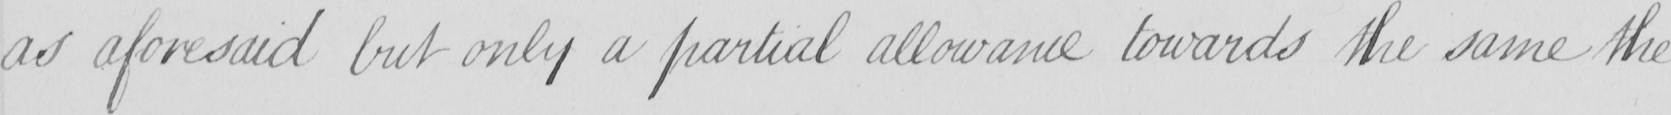Please transcribe the handwritten text in this image. as aforesaid but only a partial allowance towards the same the 